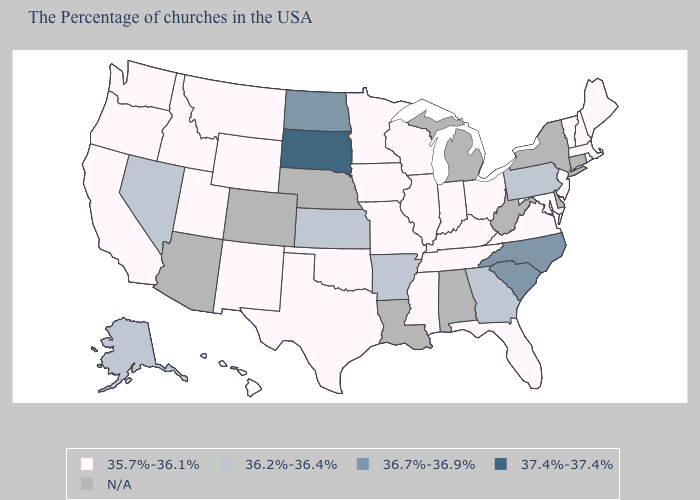Name the states that have a value in the range 35.7%-36.1%?
Short answer required. Maine, Massachusetts, Rhode Island, New Hampshire, Vermont, New Jersey, Maryland, Virginia, Ohio, Florida, Kentucky, Indiana, Tennessee, Wisconsin, Illinois, Mississippi, Missouri, Minnesota, Iowa, Oklahoma, Texas, Wyoming, New Mexico, Utah, Montana, Idaho, California, Washington, Oregon, Hawaii. Does Nevada have the highest value in the West?
Short answer required. Yes. Name the states that have a value in the range N/A?
Keep it brief. Connecticut, New York, Delaware, West Virginia, Michigan, Alabama, Louisiana, Nebraska, Colorado, Arizona. Name the states that have a value in the range 36.7%-36.9%?
Answer briefly. North Carolina, South Carolina, North Dakota. Does South Dakota have the highest value in the USA?
Answer briefly. Yes. What is the lowest value in the West?
Concise answer only. 35.7%-36.1%. Name the states that have a value in the range 37.4%-37.4%?
Write a very short answer. South Dakota. What is the value of New Jersey?
Write a very short answer. 35.7%-36.1%. Does North Carolina have the highest value in the South?
Give a very brief answer. Yes. Which states hav the highest value in the West?
Quick response, please. Nevada, Alaska. What is the lowest value in the USA?
Concise answer only. 35.7%-36.1%. What is the value of Kansas?
Answer briefly. 36.2%-36.4%. What is the value of South Carolina?
Be succinct. 36.7%-36.9%. Name the states that have a value in the range 35.7%-36.1%?
Short answer required. Maine, Massachusetts, Rhode Island, New Hampshire, Vermont, New Jersey, Maryland, Virginia, Ohio, Florida, Kentucky, Indiana, Tennessee, Wisconsin, Illinois, Mississippi, Missouri, Minnesota, Iowa, Oklahoma, Texas, Wyoming, New Mexico, Utah, Montana, Idaho, California, Washington, Oregon, Hawaii. Does South Dakota have the highest value in the USA?
Keep it brief. Yes. 